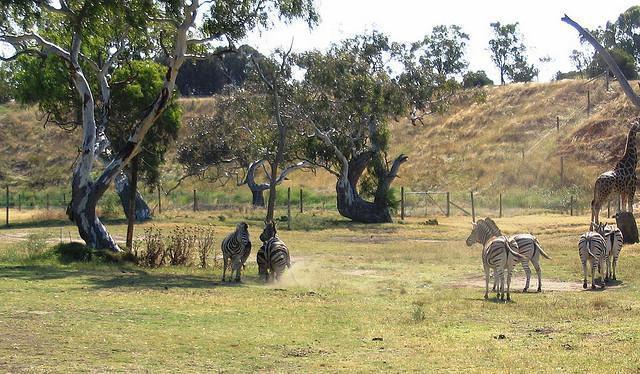How many animals in the shot?
Give a very brief answer. 7. How many people have their hands up on their head?
Give a very brief answer. 0. 